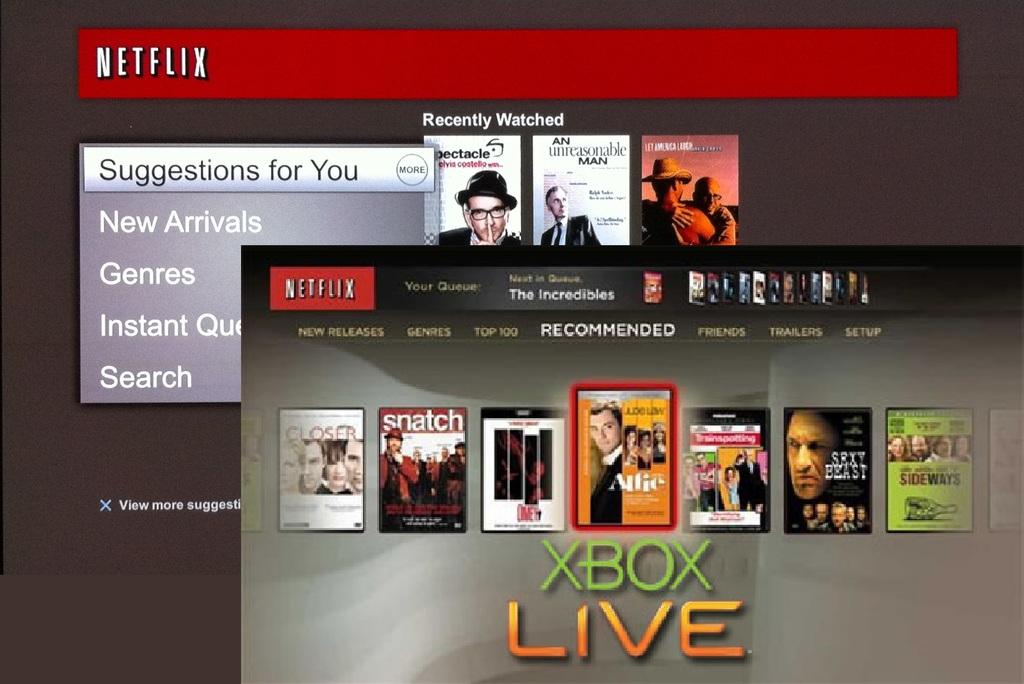What options are there for you to choose from?
Provide a short and direct response. Closer, snatch, one, alfie, sexybeast, side ways. What app is this?
Provide a succinct answer. Netflix. 